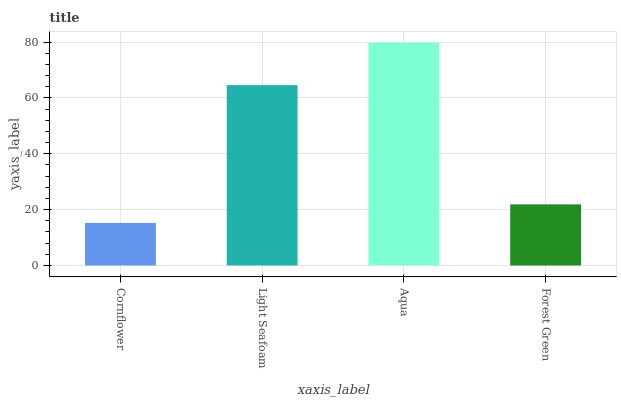Is Cornflower the minimum?
Answer yes or no. Yes. Is Aqua the maximum?
Answer yes or no. Yes. Is Light Seafoam the minimum?
Answer yes or no. No. Is Light Seafoam the maximum?
Answer yes or no. No. Is Light Seafoam greater than Cornflower?
Answer yes or no. Yes. Is Cornflower less than Light Seafoam?
Answer yes or no. Yes. Is Cornflower greater than Light Seafoam?
Answer yes or no. No. Is Light Seafoam less than Cornflower?
Answer yes or no. No. Is Light Seafoam the high median?
Answer yes or no. Yes. Is Forest Green the low median?
Answer yes or no. Yes. Is Forest Green the high median?
Answer yes or no. No. Is Aqua the low median?
Answer yes or no. No. 